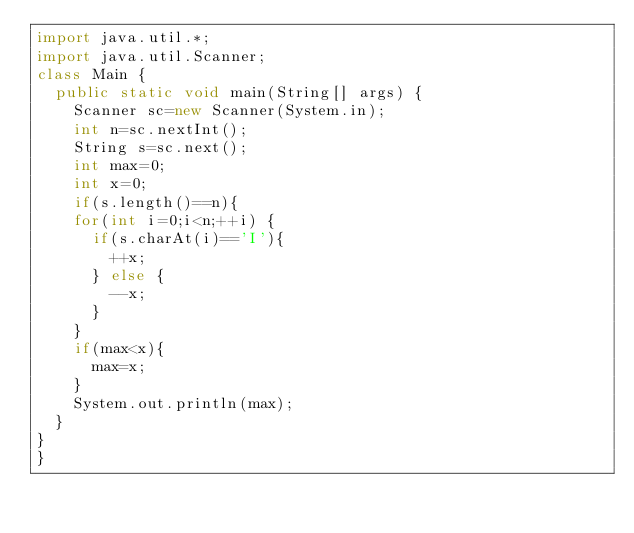Convert code to text. <code><loc_0><loc_0><loc_500><loc_500><_Java_>import java.util.*;
import java.util.Scanner;
class Main {
  public static void main(String[] args) {
    Scanner sc=new Scanner(System.in);
    int n=sc.nextInt();
    String s=sc.next();
    int max=0;
    int x=0;
    if(s.length()==n){
    for(int i=0;i<n;++i) {
      if(s.charAt(i)=='I'){
        ++x;
      } else {
        --x;
      }
    }
    if(max<x){
      max=x;
    }
    System.out.println(max);
  }
}
}</code> 